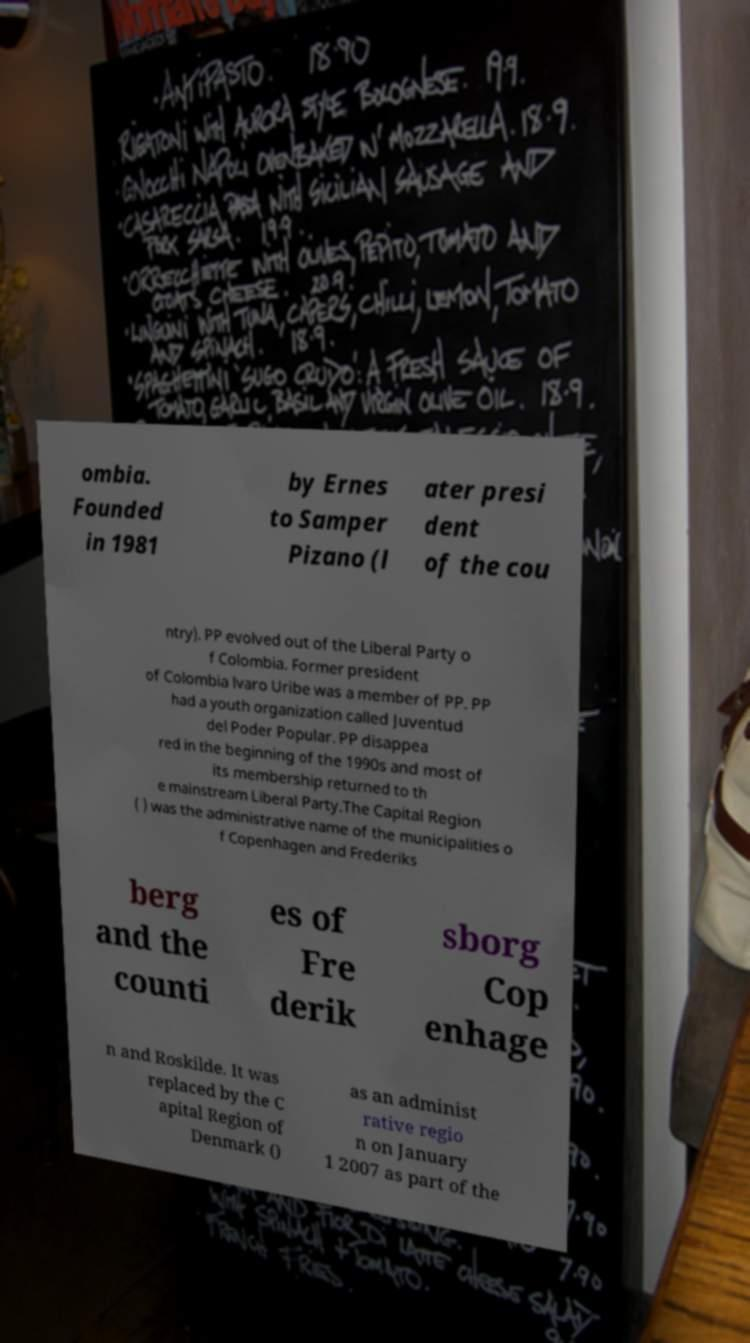There's text embedded in this image that I need extracted. Can you transcribe it verbatim? ombia. Founded in 1981 by Ernes to Samper Pizano (l ater presi dent of the cou ntry). PP evolved out of the Liberal Party o f Colombia. Former president of Colombia lvaro Uribe was a member of PP. PP had a youth organization called Juventud del Poder Popular. PP disappea red in the beginning of the 1990s and most of its membership returned to th e mainstream Liberal Party.The Capital Region ( ) was the administrative name of the municipalities o f Copenhagen and Frederiks berg and the counti es of Fre derik sborg Cop enhage n and Roskilde. It was replaced by the C apital Region of Denmark () as an administ rative regio n on January 1 2007 as part of the 